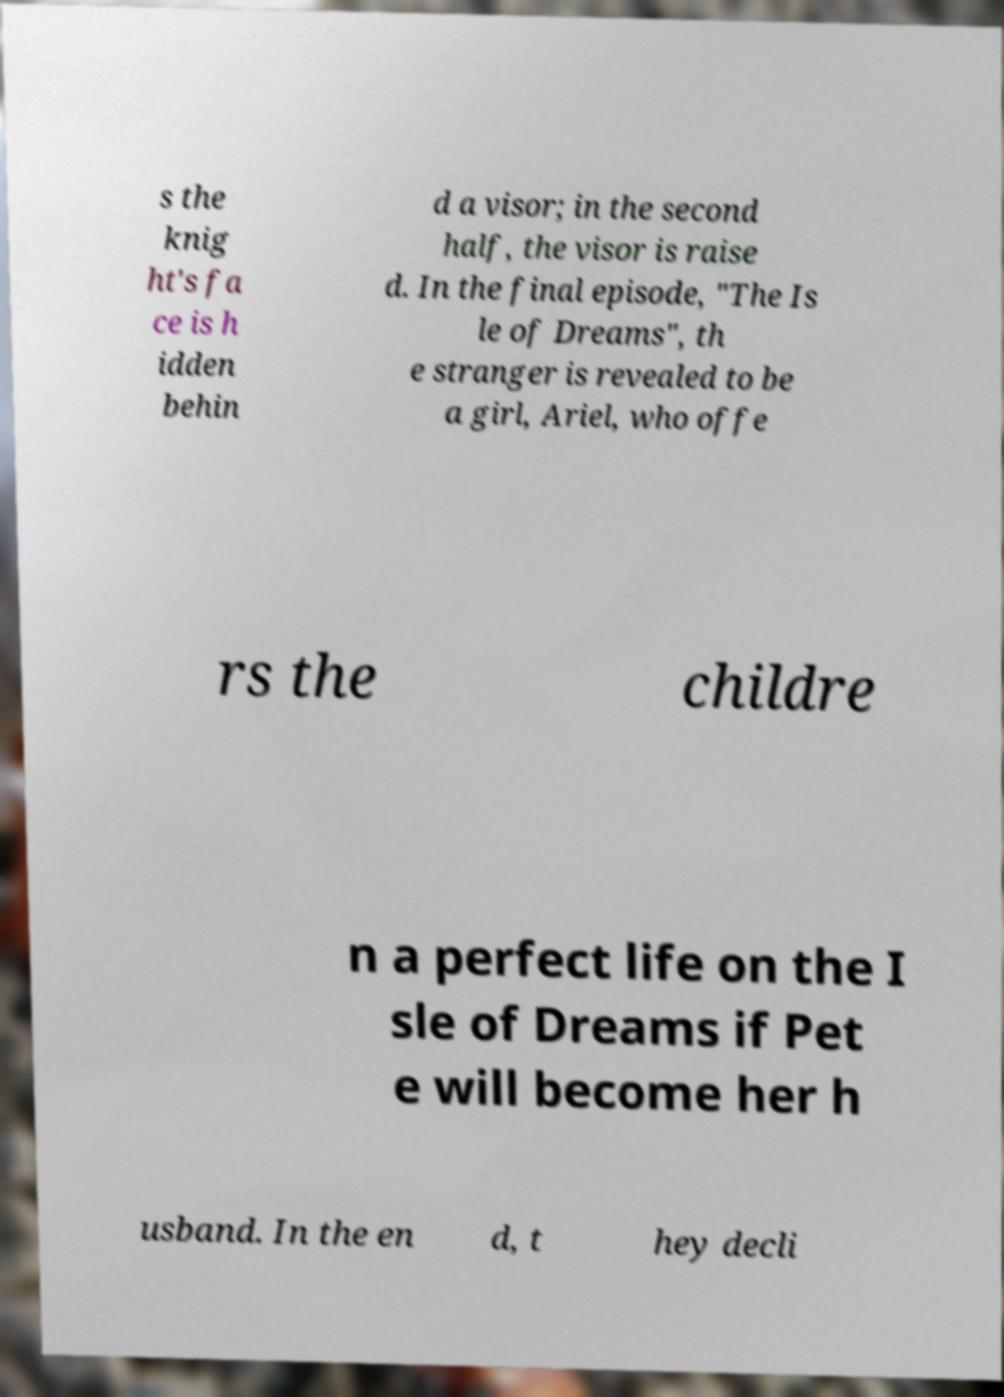For documentation purposes, I need the text within this image transcribed. Could you provide that? s the knig ht's fa ce is h idden behin d a visor; in the second half, the visor is raise d. In the final episode, "The Is le of Dreams", th e stranger is revealed to be a girl, Ariel, who offe rs the childre n a perfect life on the I sle of Dreams if Pet e will become her h usband. In the en d, t hey decli 